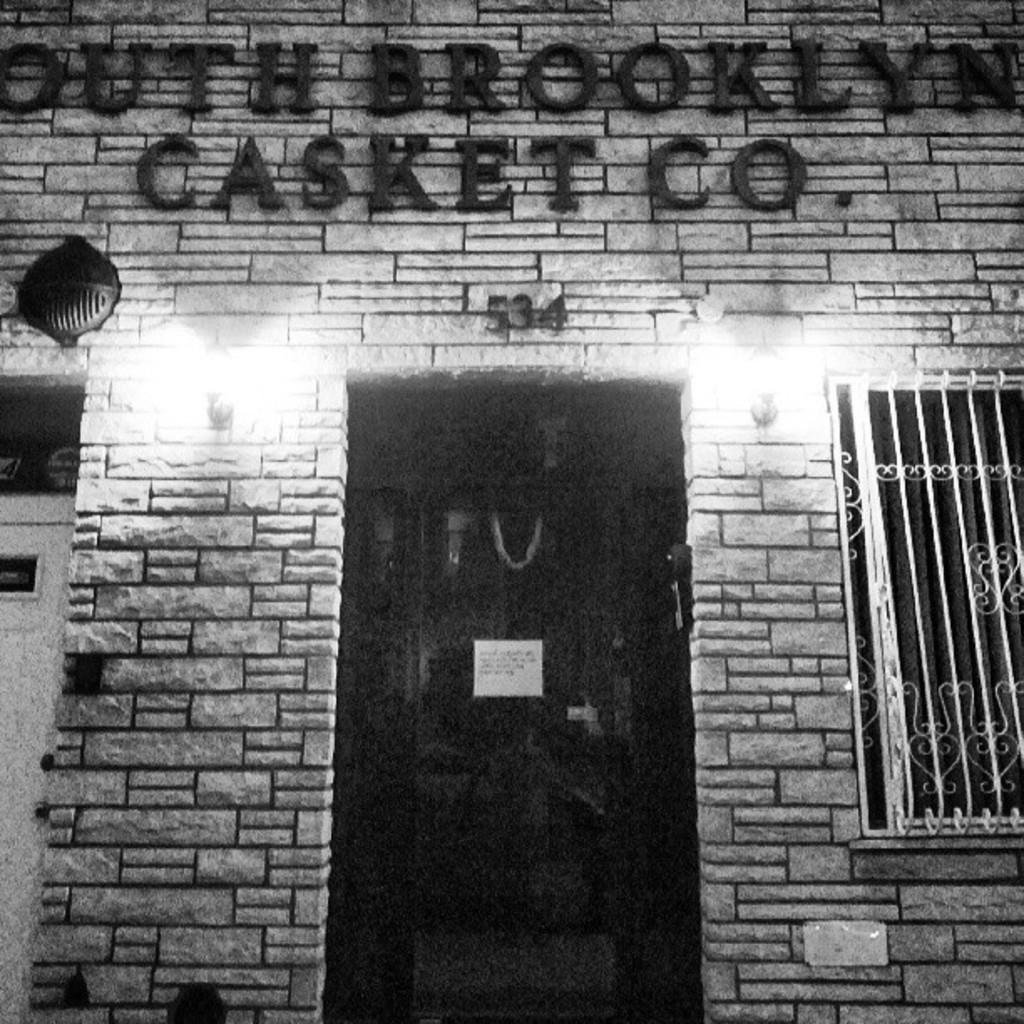What is the main structure in the center of the image? There is a building in the center of the image. What type of wall can be seen in the image? There is a brick wall in the image. What are some features of the building that can be seen in the image? There are doors, a window, and lights visible in the image. What additional signage or decoration is present in the image? There is a banner in the image, and something is written on a wall. Are there any other objects or elements in the image? Yes, there are other objects in the image. Can you see a van driving down the street in the image? There is no van or street visible in the image; it primarily features a building and its surroundings. 